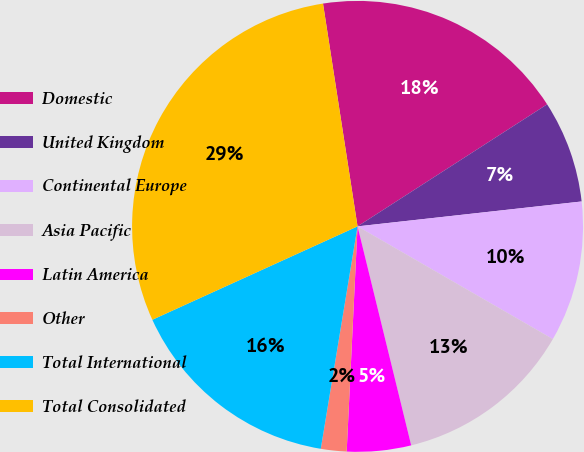Convert chart to OTSL. <chart><loc_0><loc_0><loc_500><loc_500><pie_chart><fcel>Domestic<fcel>United Kingdom<fcel>Continental Europe<fcel>Asia Pacific<fcel>Latin America<fcel>Other<fcel>Total International<fcel>Total Consolidated<nl><fcel>18.34%<fcel>7.34%<fcel>10.09%<fcel>12.84%<fcel>4.59%<fcel>1.84%<fcel>15.59%<fcel>29.34%<nl></chart> 